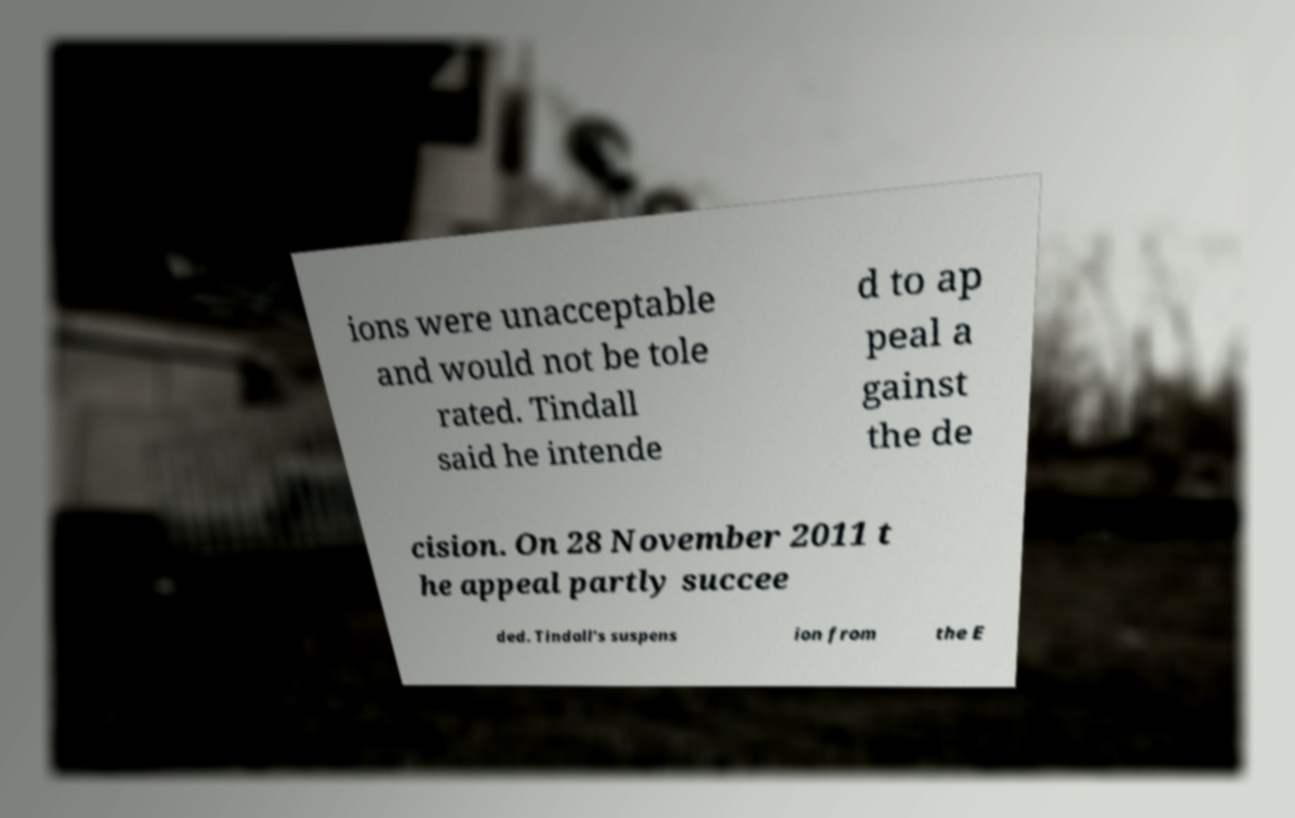Please identify and transcribe the text found in this image. ions were unacceptable and would not be tole rated. Tindall said he intende d to ap peal a gainst the de cision. On 28 November 2011 t he appeal partly succee ded. Tindall's suspens ion from the E 